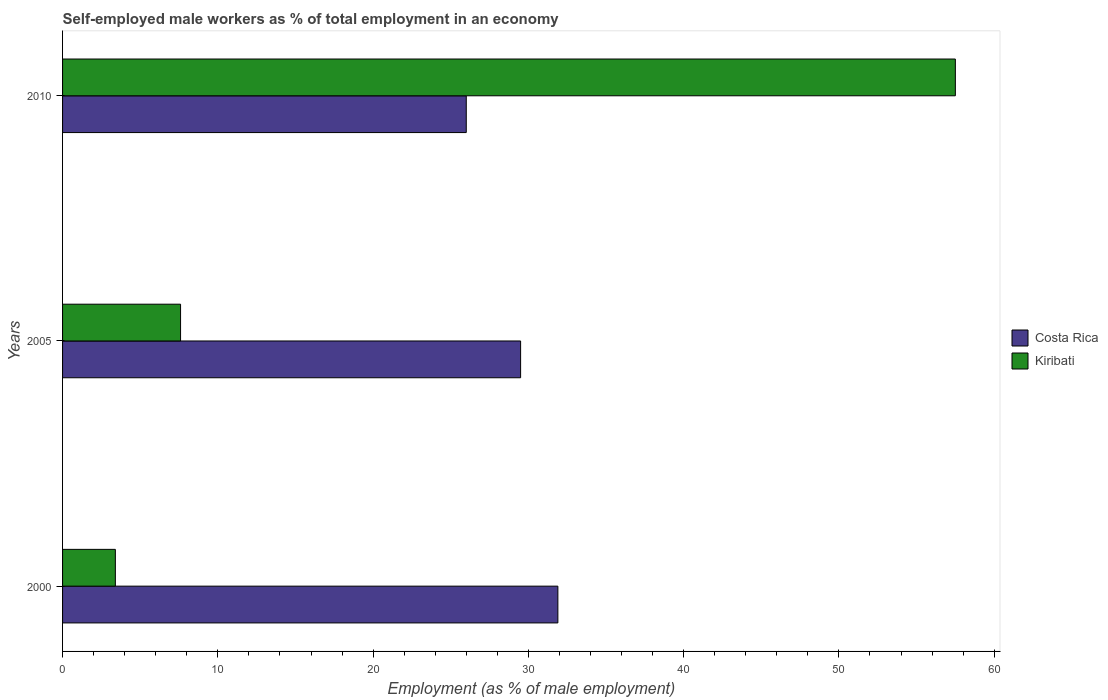How many groups of bars are there?
Give a very brief answer. 3. Are the number of bars on each tick of the Y-axis equal?
Your answer should be very brief. Yes. How many bars are there on the 2nd tick from the bottom?
Provide a short and direct response. 2. What is the label of the 1st group of bars from the top?
Offer a very short reply. 2010. What is the percentage of self-employed male workers in Kiribati in 2000?
Offer a very short reply. 3.4. Across all years, what is the maximum percentage of self-employed male workers in Costa Rica?
Offer a terse response. 31.9. Across all years, what is the minimum percentage of self-employed male workers in Costa Rica?
Your response must be concise. 26. In which year was the percentage of self-employed male workers in Kiribati maximum?
Give a very brief answer. 2010. What is the total percentage of self-employed male workers in Costa Rica in the graph?
Your answer should be compact. 87.4. What is the difference between the percentage of self-employed male workers in Costa Rica in 2000 and that in 2005?
Offer a very short reply. 2.4. What is the difference between the percentage of self-employed male workers in Kiribati in 2010 and the percentage of self-employed male workers in Costa Rica in 2000?
Offer a very short reply. 25.6. What is the average percentage of self-employed male workers in Costa Rica per year?
Ensure brevity in your answer.  29.13. In the year 2010, what is the difference between the percentage of self-employed male workers in Costa Rica and percentage of self-employed male workers in Kiribati?
Your response must be concise. -31.5. In how many years, is the percentage of self-employed male workers in Costa Rica greater than 52 %?
Offer a very short reply. 0. What is the ratio of the percentage of self-employed male workers in Costa Rica in 2000 to that in 2005?
Provide a succinct answer. 1.08. Is the percentage of self-employed male workers in Costa Rica in 2000 less than that in 2010?
Offer a very short reply. No. What is the difference between the highest and the second highest percentage of self-employed male workers in Kiribati?
Your answer should be compact. 49.9. What is the difference between the highest and the lowest percentage of self-employed male workers in Kiribati?
Provide a short and direct response. 54.1. In how many years, is the percentage of self-employed male workers in Costa Rica greater than the average percentage of self-employed male workers in Costa Rica taken over all years?
Your answer should be very brief. 2. Is the sum of the percentage of self-employed male workers in Kiribati in 2000 and 2005 greater than the maximum percentage of self-employed male workers in Costa Rica across all years?
Your answer should be very brief. No. What does the 2nd bar from the top in 2000 represents?
Make the answer very short. Costa Rica. Are all the bars in the graph horizontal?
Offer a terse response. Yes. How many years are there in the graph?
Your response must be concise. 3. Are the values on the major ticks of X-axis written in scientific E-notation?
Offer a very short reply. No. Does the graph contain any zero values?
Provide a succinct answer. No. Does the graph contain grids?
Your answer should be very brief. No. How many legend labels are there?
Give a very brief answer. 2. What is the title of the graph?
Ensure brevity in your answer.  Self-employed male workers as % of total employment in an economy. Does "Madagascar" appear as one of the legend labels in the graph?
Give a very brief answer. No. What is the label or title of the X-axis?
Offer a terse response. Employment (as % of male employment). What is the label or title of the Y-axis?
Your answer should be compact. Years. What is the Employment (as % of male employment) in Costa Rica in 2000?
Ensure brevity in your answer.  31.9. What is the Employment (as % of male employment) in Kiribati in 2000?
Offer a very short reply. 3.4. What is the Employment (as % of male employment) in Costa Rica in 2005?
Offer a very short reply. 29.5. What is the Employment (as % of male employment) in Kiribati in 2005?
Provide a succinct answer. 7.6. What is the Employment (as % of male employment) of Kiribati in 2010?
Offer a terse response. 57.5. Across all years, what is the maximum Employment (as % of male employment) of Costa Rica?
Keep it short and to the point. 31.9. Across all years, what is the maximum Employment (as % of male employment) in Kiribati?
Your answer should be compact. 57.5. Across all years, what is the minimum Employment (as % of male employment) in Kiribati?
Provide a short and direct response. 3.4. What is the total Employment (as % of male employment) of Costa Rica in the graph?
Your response must be concise. 87.4. What is the total Employment (as % of male employment) in Kiribati in the graph?
Offer a very short reply. 68.5. What is the difference between the Employment (as % of male employment) of Kiribati in 2000 and that in 2010?
Provide a succinct answer. -54.1. What is the difference between the Employment (as % of male employment) in Kiribati in 2005 and that in 2010?
Your response must be concise. -49.9. What is the difference between the Employment (as % of male employment) of Costa Rica in 2000 and the Employment (as % of male employment) of Kiribati in 2005?
Your answer should be very brief. 24.3. What is the difference between the Employment (as % of male employment) of Costa Rica in 2000 and the Employment (as % of male employment) of Kiribati in 2010?
Offer a very short reply. -25.6. What is the average Employment (as % of male employment) in Costa Rica per year?
Provide a short and direct response. 29.13. What is the average Employment (as % of male employment) in Kiribati per year?
Offer a very short reply. 22.83. In the year 2000, what is the difference between the Employment (as % of male employment) in Costa Rica and Employment (as % of male employment) in Kiribati?
Provide a succinct answer. 28.5. In the year 2005, what is the difference between the Employment (as % of male employment) of Costa Rica and Employment (as % of male employment) of Kiribati?
Ensure brevity in your answer.  21.9. In the year 2010, what is the difference between the Employment (as % of male employment) in Costa Rica and Employment (as % of male employment) in Kiribati?
Your answer should be very brief. -31.5. What is the ratio of the Employment (as % of male employment) in Costa Rica in 2000 to that in 2005?
Your response must be concise. 1.08. What is the ratio of the Employment (as % of male employment) in Kiribati in 2000 to that in 2005?
Keep it short and to the point. 0.45. What is the ratio of the Employment (as % of male employment) in Costa Rica in 2000 to that in 2010?
Your response must be concise. 1.23. What is the ratio of the Employment (as % of male employment) of Kiribati in 2000 to that in 2010?
Keep it short and to the point. 0.06. What is the ratio of the Employment (as % of male employment) in Costa Rica in 2005 to that in 2010?
Your answer should be compact. 1.13. What is the ratio of the Employment (as % of male employment) of Kiribati in 2005 to that in 2010?
Give a very brief answer. 0.13. What is the difference between the highest and the second highest Employment (as % of male employment) in Costa Rica?
Provide a succinct answer. 2.4. What is the difference between the highest and the second highest Employment (as % of male employment) of Kiribati?
Provide a short and direct response. 49.9. What is the difference between the highest and the lowest Employment (as % of male employment) of Kiribati?
Offer a very short reply. 54.1. 